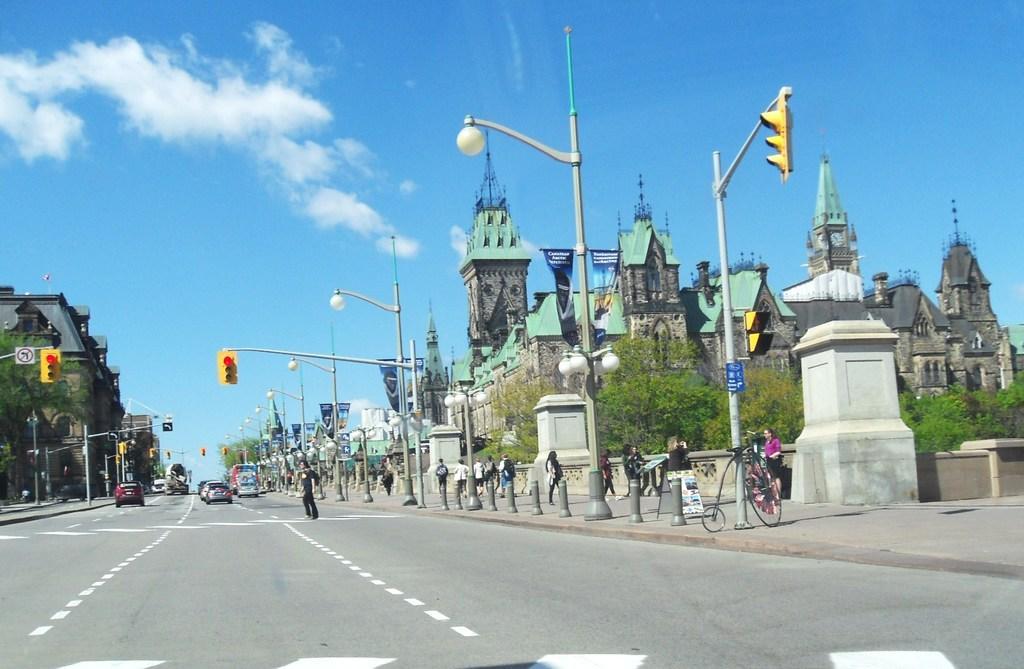How would you summarize this image in a sentence or two? In this image there are persons walking on the road. In the background there are cars moving on the road and there are buildings. On the right side there are trees, there are poles, and there is a bicycle in the front and the sky is cloudy. 